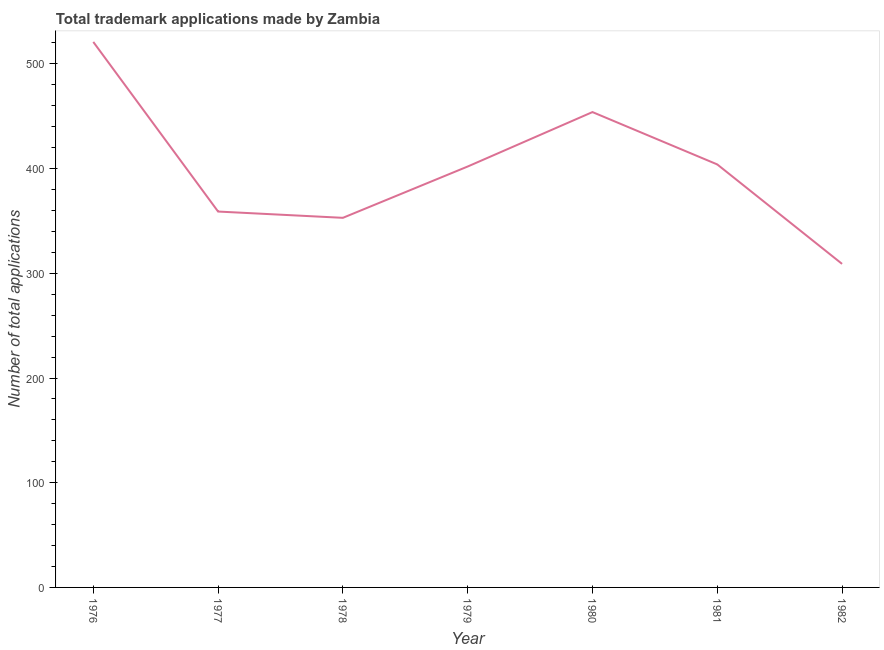What is the number of trademark applications in 1977?
Make the answer very short. 359. Across all years, what is the maximum number of trademark applications?
Your answer should be very brief. 521. Across all years, what is the minimum number of trademark applications?
Provide a short and direct response. 309. In which year was the number of trademark applications maximum?
Provide a short and direct response. 1976. What is the sum of the number of trademark applications?
Make the answer very short. 2802. What is the difference between the number of trademark applications in 1977 and 1978?
Your response must be concise. 6. What is the average number of trademark applications per year?
Your answer should be very brief. 400.29. What is the median number of trademark applications?
Keep it short and to the point. 402. Do a majority of the years between 1982 and 1978 (inclusive) have number of trademark applications greater than 240 ?
Keep it short and to the point. Yes. What is the ratio of the number of trademark applications in 1976 to that in 1979?
Provide a succinct answer. 1.3. What is the difference between the highest and the lowest number of trademark applications?
Your answer should be very brief. 212. In how many years, is the number of trademark applications greater than the average number of trademark applications taken over all years?
Ensure brevity in your answer.  4. How many lines are there?
Offer a terse response. 1. How many years are there in the graph?
Your answer should be compact. 7. What is the difference between two consecutive major ticks on the Y-axis?
Offer a very short reply. 100. Does the graph contain any zero values?
Keep it short and to the point. No. What is the title of the graph?
Offer a terse response. Total trademark applications made by Zambia. What is the label or title of the Y-axis?
Your answer should be compact. Number of total applications. What is the Number of total applications in 1976?
Keep it short and to the point. 521. What is the Number of total applications of 1977?
Your response must be concise. 359. What is the Number of total applications in 1978?
Give a very brief answer. 353. What is the Number of total applications in 1979?
Provide a short and direct response. 402. What is the Number of total applications in 1980?
Keep it short and to the point. 454. What is the Number of total applications of 1981?
Provide a short and direct response. 404. What is the Number of total applications of 1982?
Your response must be concise. 309. What is the difference between the Number of total applications in 1976 and 1977?
Your answer should be very brief. 162. What is the difference between the Number of total applications in 1976 and 1978?
Offer a very short reply. 168. What is the difference between the Number of total applications in 1976 and 1979?
Make the answer very short. 119. What is the difference between the Number of total applications in 1976 and 1980?
Provide a succinct answer. 67. What is the difference between the Number of total applications in 1976 and 1981?
Give a very brief answer. 117. What is the difference between the Number of total applications in 1976 and 1982?
Give a very brief answer. 212. What is the difference between the Number of total applications in 1977 and 1978?
Offer a terse response. 6. What is the difference between the Number of total applications in 1977 and 1979?
Give a very brief answer. -43. What is the difference between the Number of total applications in 1977 and 1980?
Offer a terse response. -95. What is the difference between the Number of total applications in 1977 and 1981?
Give a very brief answer. -45. What is the difference between the Number of total applications in 1978 and 1979?
Make the answer very short. -49. What is the difference between the Number of total applications in 1978 and 1980?
Offer a very short reply. -101. What is the difference between the Number of total applications in 1978 and 1981?
Give a very brief answer. -51. What is the difference between the Number of total applications in 1979 and 1980?
Offer a terse response. -52. What is the difference between the Number of total applications in 1979 and 1981?
Your answer should be compact. -2. What is the difference between the Number of total applications in 1979 and 1982?
Offer a terse response. 93. What is the difference between the Number of total applications in 1980 and 1981?
Provide a short and direct response. 50. What is the difference between the Number of total applications in 1980 and 1982?
Make the answer very short. 145. What is the difference between the Number of total applications in 1981 and 1982?
Your answer should be very brief. 95. What is the ratio of the Number of total applications in 1976 to that in 1977?
Your answer should be compact. 1.45. What is the ratio of the Number of total applications in 1976 to that in 1978?
Make the answer very short. 1.48. What is the ratio of the Number of total applications in 1976 to that in 1979?
Make the answer very short. 1.3. What is the ratio of the Number of total applications in 1976 to that in 1980?
Give a very brief answer. 1.15. What is the ratio of the Number of total applications in 1976 to that in 1981?
Give a very brief answer. 1.29. What is the ratio of the Number of total applications in 1976 to that in 1982?
Your answer should be very brief. 1.69. What is the ratio of the Number of total applications in 1977 to that in 1979?
Make the answer very short. 0.89. What is the ratio of the Number of total applications in 1977 to that in 1980?
Offer a very short reply. 0.79. What is the ratio of the Number of total applications in 1977 to that in 1981?
Make the answer very short. 0.89. What is the ratio of the Number of total applications in 1977 to that in 1982?
Ensure brevity in your answer.  1.16. What is the ratio of the Number of total applications in 1978 to that in 1979?
Your response must be concise. 0.88. What is the ratio of the Number of total applications in 1978 to that in 1980?
Give a very brief answer. 0.78. What is the ratio of the Number of total applications in 1978 to that in 1981?
Your answer should be compact. 0.87. What is the ratio of the Number of total applications in 1978 to that in 1982?
Offer a terse response. 1.14. What is the ratio of the Number of total applications in 1979 to that in 1980?
Make the answer very short. 0.89. What is the ratio of the Number of total applications in 1979 to that in 1981?
Make the answer very short. 0.99. What is the ratio of the Number of total applications in 1979 to that in 1982?
Your answer should be very brief. 1.3. What is the ratio of the Number of total applications in 1980 to that in 1981?
Give a very brief answer. 1.12. What is the ratio of the Number of total applications in 1980 to that in 1982?
Offer a terse response. 1.47. What is the ratio of the Number of total applications in 1981 to that in 1982?
Your response must be concise. 1.31. 